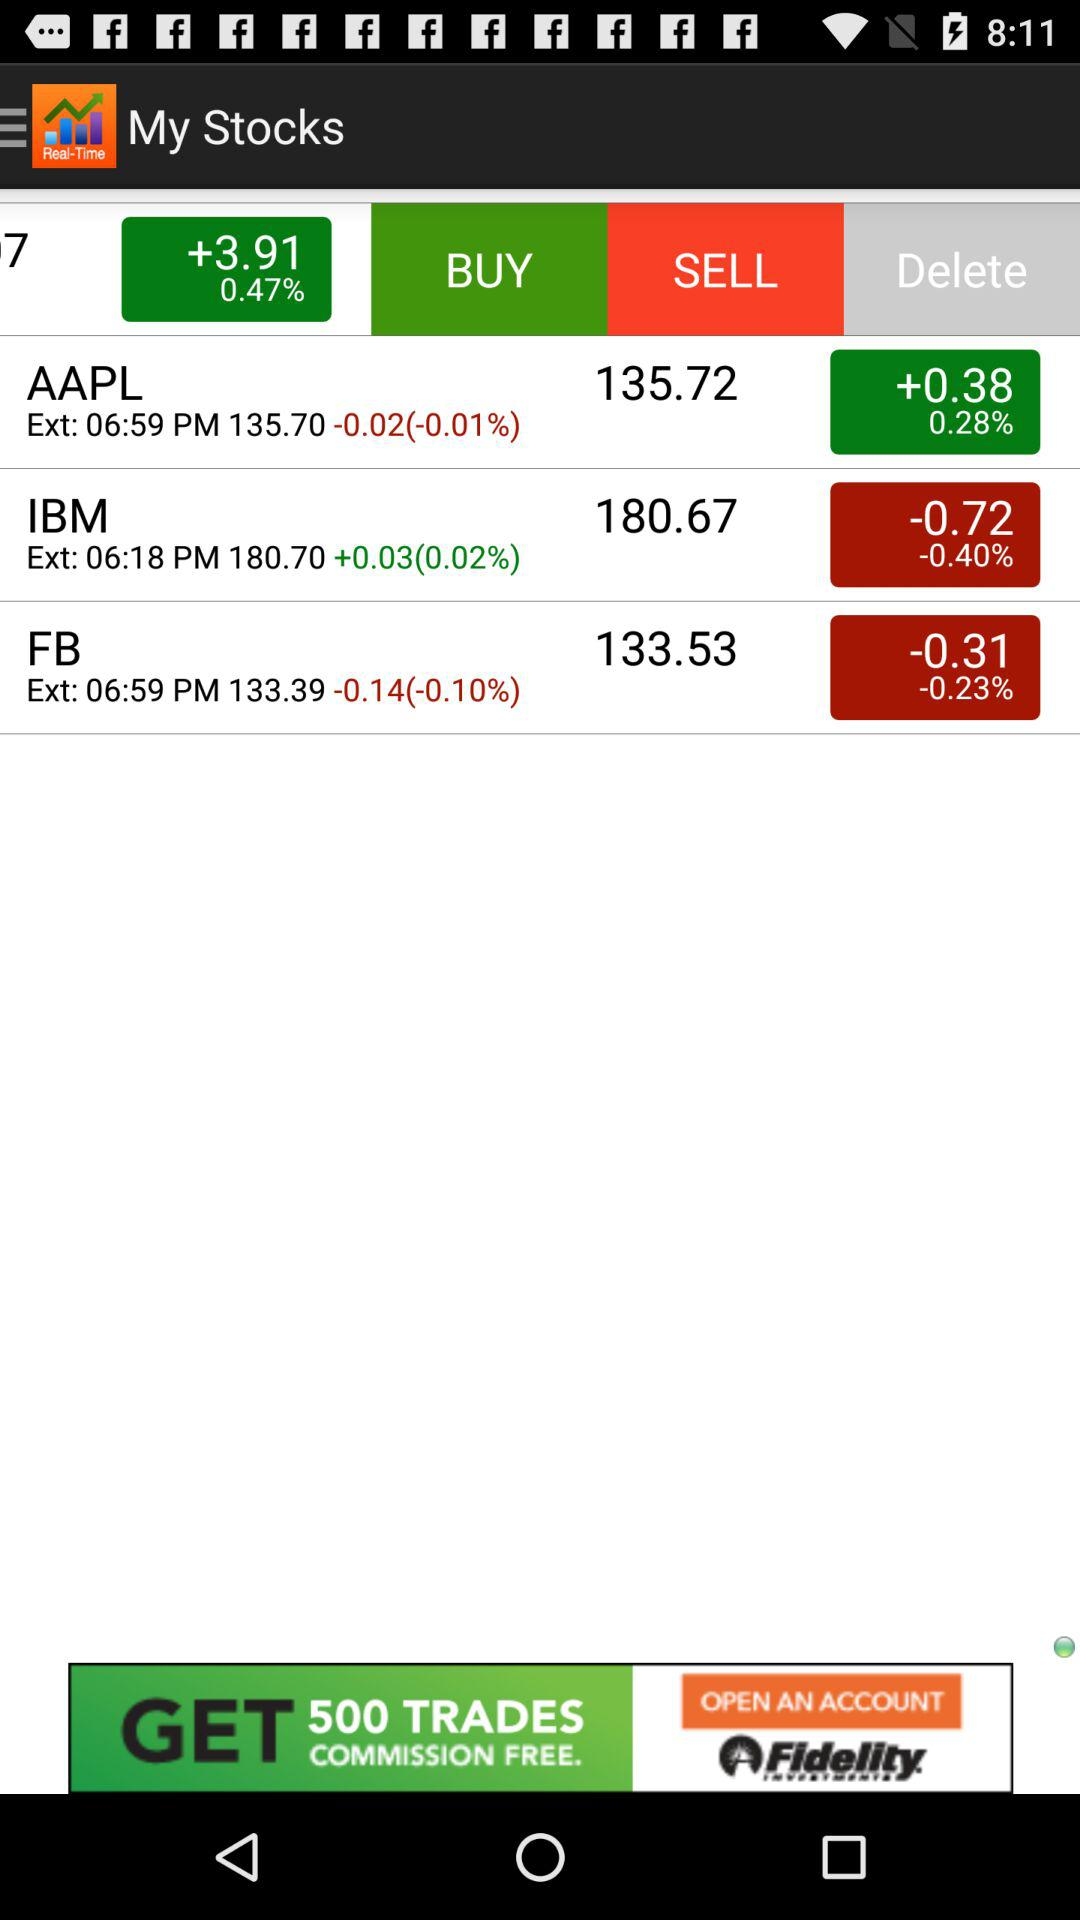What is the change in the price of IBM? The change in the price of IBM is -0.72. 